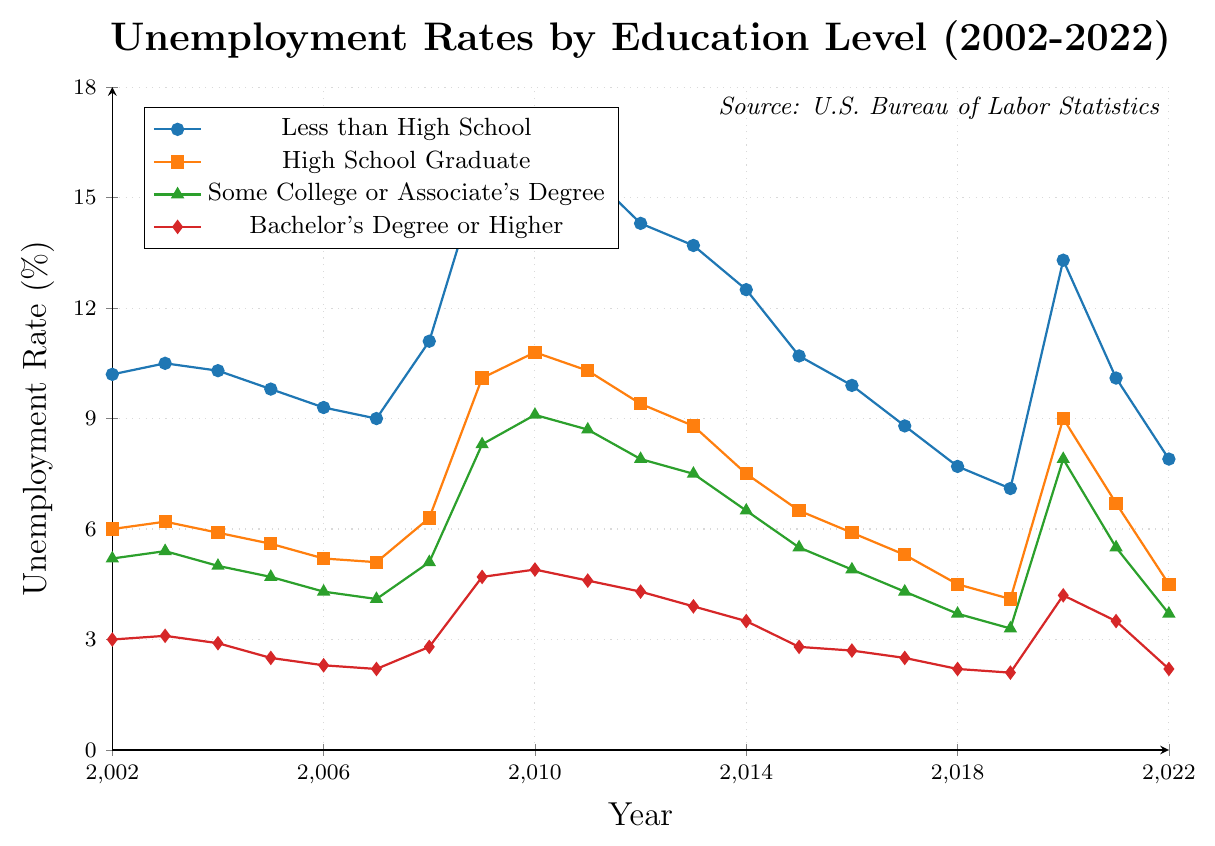What was the peak unemployment rate for people with less than a high school education? The red line representing "Less than High School" reaches its highest point in 2010 at 16.2%. This is the peak unemployment rate for this group.
Answer: 16.2% How many years did the unemployment rate for high school graduates exceed 9%? Checking the orange line representing "High School Graduate," you see it exceeded 9% in 2009, 2010, 2011, and 2020. These are 4 years in total.
Answer: 4 In which year did people with a Bachelor’s degree or higher experience the lowest unemployment rate? The purple line representing "Bachelor's Degree or Higher" reaches its lowest point in 2019 at 2.1%.
Answer: 2019 What is the average unemployment rate for those with some college or an associate's degree over the 20 years? Sum up the data points for "Some College or Associate's Degree" and divide by 21 (the number of years). Sum of the rates is 127.4, and average is 127.4/21 = ~6.07.
Answer: ~6.07% In 2022, what is the difference in unemployment rates between those with less than a high school education and those with a Bachelor’s degree or higher? The unemployment rate for "Less than High School" in 2022 is 7.9% and for "Bachelor's Degree or Higher" is 2.2%. The difference is 7.9% - 2.2% = 5.7%.
Answer: 5.7% Which education level saw the biggest increase in unemployment rate between 2019 and 2020? Calculate the difference in unemployment rates for each education level between 2019 and 2020: (7.1 to 13.3 for Less than High School, 4.1 to 9.0 for High School Graduate, 3.3 to 7.9 for Some College or Associate's Degree, and 2.1 to 4.2 for Bachelor's Degree or Higher). "Less than High School" saw an increase of 6.2%, which is the biggest among the groups.
Answer: Less than High School Compare the unemployment rates of individuals with Bachelor’s degrees or higher in 2008 and 2020. Which year had a higher rate, and by how much? The unemployment rate for "Bachelor's Degree or Higher" was 2.8% in 2008 and 4.2% in 2020. The rate in 2020 is higher by 4.2% - 2.8% = 1.4%.
Answer: 2020, by 1.4% How did the unemployment rate for high school graduates change from 2011 to 2019? In 2011, the unemployment rate for "High School Graduate" was 10.3%. In 2019, it was 4.1%. The rate decreased by 10.3% - 4.1% = 6.2%.
Answer: Decreased by 6.2% What is the visual trend for unemployment rates for all education levels during the 2009 recession? Visually, you see all lines rise dramatically in 2009. "Less than High School" peaks highest at 15.8%, followed by the others showing a significant increase.
Answer: All levels increased Between 2002 and 2022, what general trend can be observed in the unemployment rates across all education levels? Observing all lines from 2002 to 2022, there is a spike in 2009, but post that, a general decline towards 2022 can be noted across all education levels.
Answer: General decline after 2009 spike 